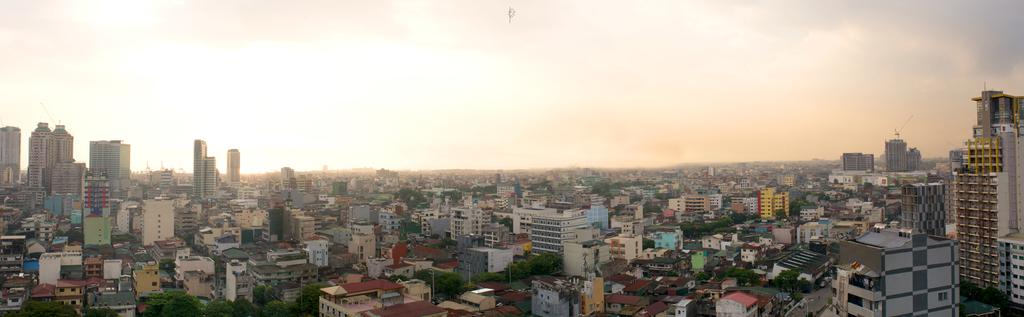What type of structures can be seen in the image? There are buildings, skyscrapers, and poles in the image. What type of infrastructure is present in the image? There are roads in the image. What type of vegetation can be seen in the image? There are trees in the image. What is visible in the sky in the image? The sky is visible in the image, and clouds are present. What grade does the toy doctor receive in the image? There is no toy or doctor present in the image; it features buildings, roads, skyscrapers, poles, trees, and a sky with clouds. 